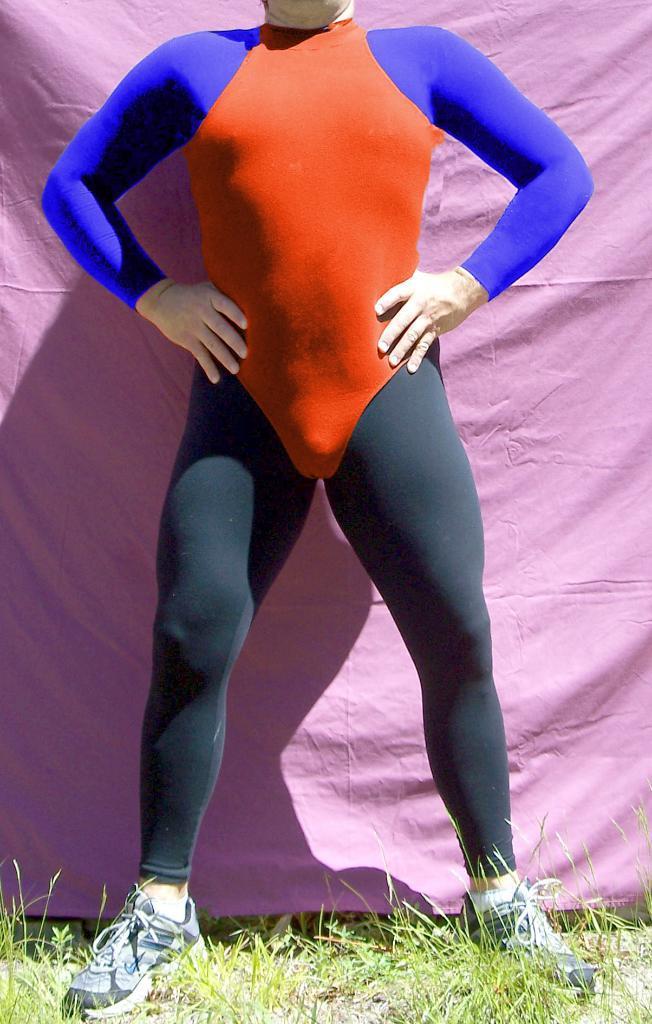Please provide a concise description of this image. There is a man wearing orange, blue and black dress is standing on the ground. In the background it is pink cloth. On the ground there is grass. 